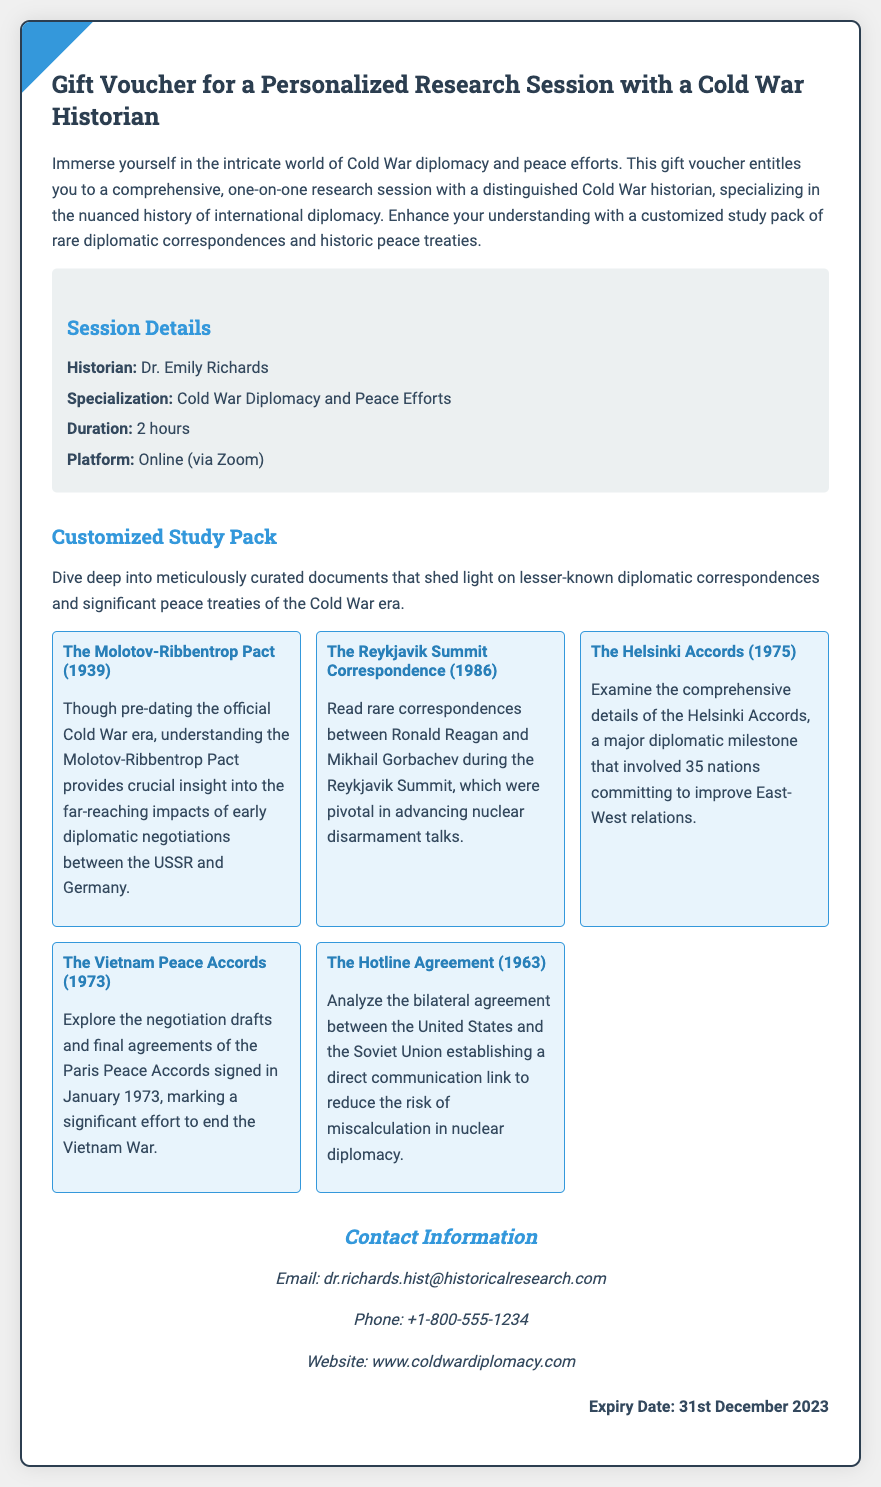what is the name of the historian offering the session? The name of the historian is mentioned in the session details of the document.
Answer: Dr. Emily Richards what is the duration of the research session? The duration of the session is specified in the session details.
Answer: 2 hours what is the platform used for the session? The platform for the session is indicated in the session details.
Answer: Online (via Zoom) which document relates to the correspondence between Reagan and Gorbachev? The specific document that discusses Reagan and Gorbachev's correspondence is listed in the documents section.
Answer: The Reykjavik Summit Correspondence (1986) how many documents are included in the customized study pack? The total number of documents is counted from the documents section.
Answer: 5 documents what is the expiry date of the gift voucher? The expiry date is provided at the end of the document.
Answer: 31st December 2023 what type of insights does the gift voucher offer? The insights offered are detailed in the introduction of the document.
Answer: Cold War diplomacy and peace efforts what is the primary focus of Dr. Emily Richards' specialization? The specialization focus is noted in the session details.
Answer: Cold War Diplomacy and Peace Efforts what color is used for the document backgrounds? The background color is described in the style section of the document.
Answer: #fff (white) 